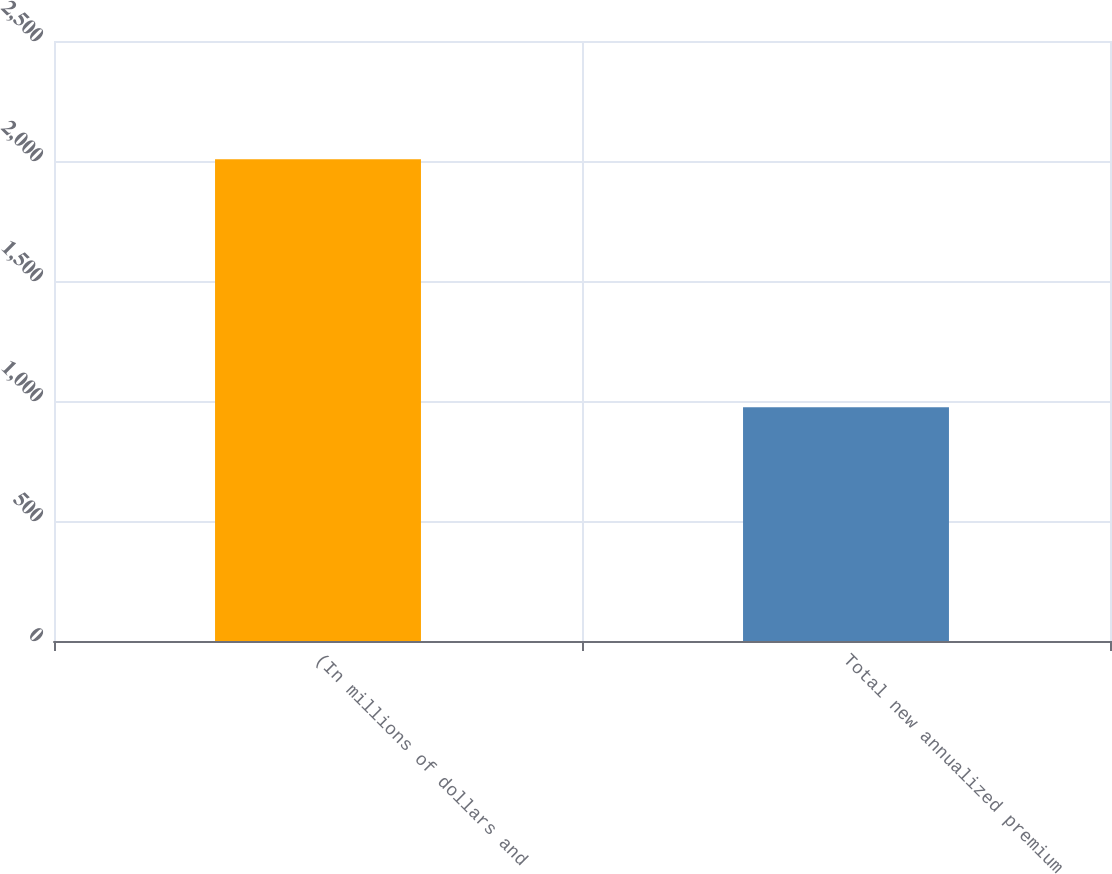<chart> <loc_0><loc_0><loc_500><loc_500><bar_chart><fcel>(In millions of dollars and<fcel>Total new annualized premium<nl><fcel>2007<fcel>974<nl></chart> 